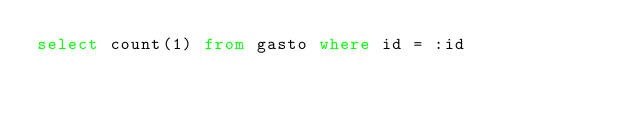Convert code to text. <code><loc_0><loc_0><loc_500><loc_500><_SQL_>select count(1) from gasto where id = :id</code> 